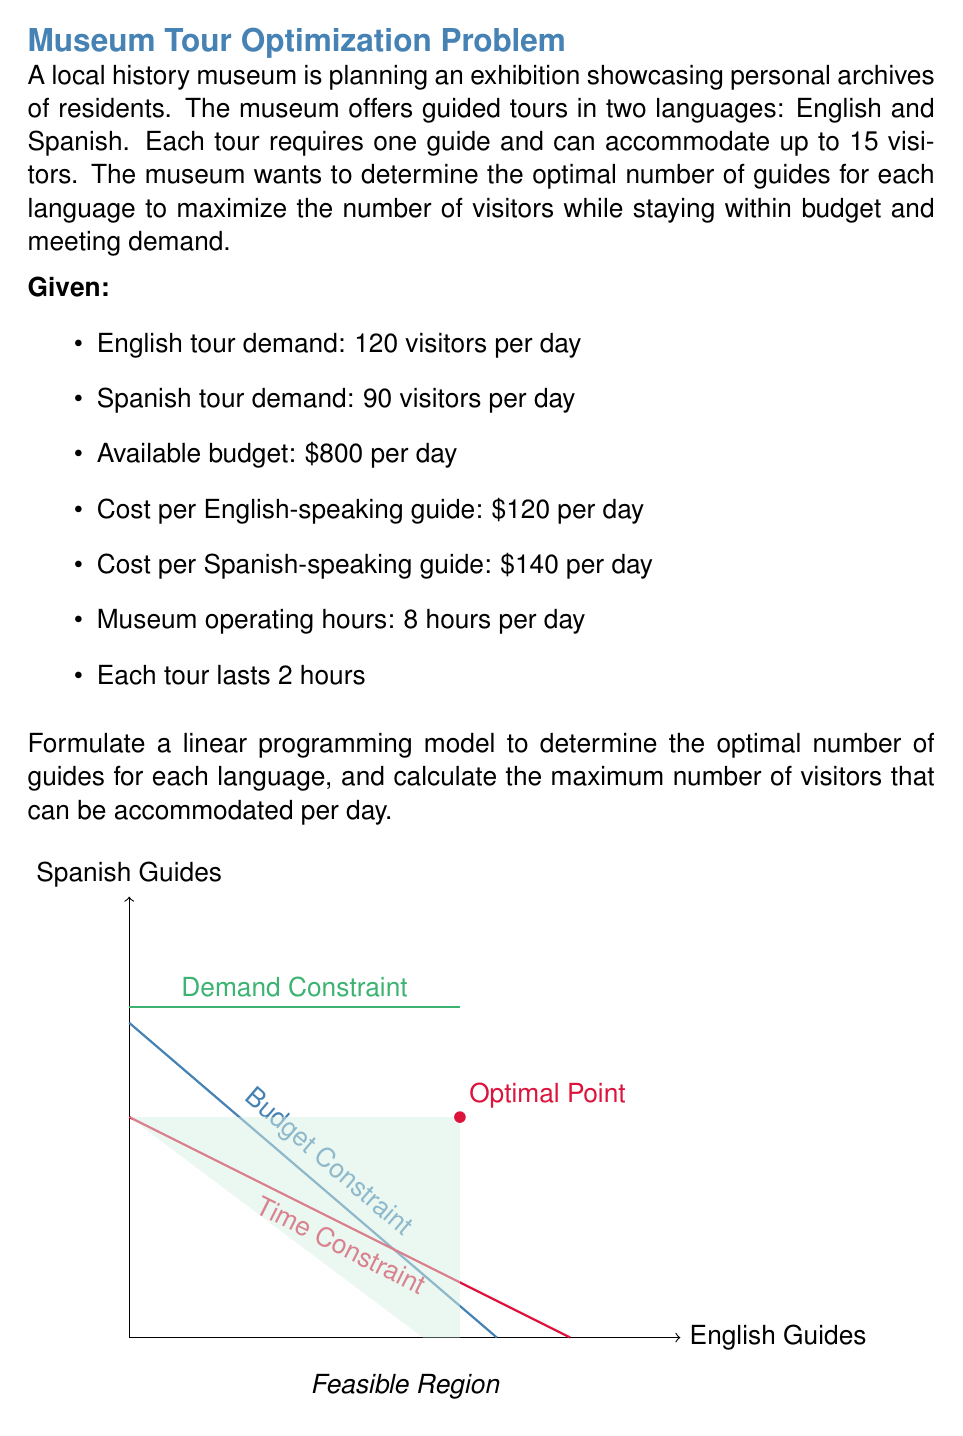Help me with this question. Let's approach this problem step-by-step:

1) Define variables:
   Let $x$ = number of English-speaking guides
   Let $y$ = number of Spanish-speaking guides

2) Objective function:
   Maximize $Z = 15(2x + 2y)$ (total visitors per day)

3) Constraints:
   a) Budget constraint: $120x + 140y \leq 800$
   b) Time constraint: $2x + 2y \leq 8$ (tours can't exceed operating hours)
   c) Demand constraints: 
      $30x \geq 120$ (English demand)
      $30y \geq 90$ (Spanish demand)
   d) Non-negativity: $x \geq 0$, $y \geq 0$

4) Simplify constraints:
   a) $3x + 7y \leq 40$
   b) $x + y \leq 4$
   c) $x \geq 4$
      $y \geq 3$

5) Graph the constraints and identify the feasible region (see figure in question).

6) The optimal solution will be at one of the corner points of the feasible region. The relevant corner points are:
   (4, 3) and (6, 2)

7) Evaluate the objective function at these points:
   At (4, 3): $Z = 15(2(4) + 2(3)) = 210$
   At (6, 2): $Z = 15(2(6) + 2(2)) = 240$

8) The maximum value occurs at (6, 2), so this is our optimal solution.

Therefore, the optimal staffing is 6 English-speaking guides and 2 Spanish-speaking guides.

9) Calculate the maximum number of visitors:
   $15(2(6) + 2(2)) = 240$ visitors per day
Answer: 6 English guides, 2 Spanish guides; 240 visitors/day 